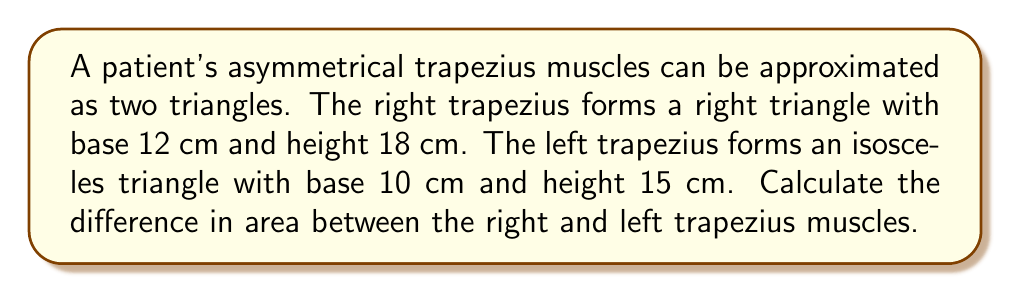Teach me how to tackle this problem. 1. Calculate the area of the right trapezius (right triangle):
   $$A_r = \frac{1}{2} \times base \times height$$
   $$A_r = \frac{1}{2} \times 12 \times 18 = 108 \text{ cm}^2$$

2. Calculate the area of the left trapezius (isosceles triangle):
   $$A_l = \frac{1}{2} \times base \times height$$
   $$A_l = \frac{1}{2} \times 10 \times 15 = 75 \text{ cm}^2$$

3. Calculate the difference in area:
   $$\text{Difference} = A_r - A_l = 108 - 75 = 33 \text{ cm}^2$$

[asy]
unitsize(0.2cm);
draw((0,0)--(12,0)--(12,18)--cycle);
draw((20,0)--(25,15)--(30,0)--cycle);
label("12 cm", (6,-1));
label("18 cm", (13,9));
label("10 cm", (25,-1));
label("15 cm", (25,7.5));
label("Right", (4,6));
label("Left", (25,5));
[/asy]
Answer: $33 \text{ cm}^2$ 